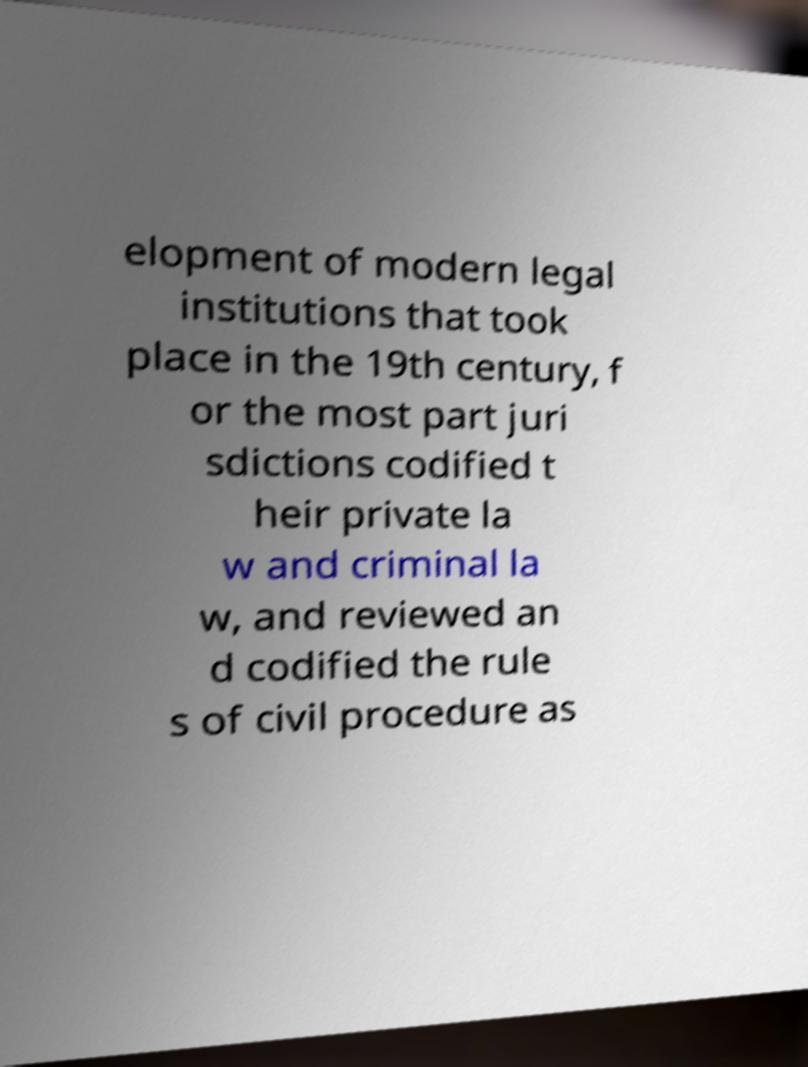There's text embedded in this image that I need extracted. Can you transcribe it verbatim? elopment of modern legal institutions that took place in the 19th century, f or the most part juri sdictions codified t heir private la w and criminal la w, and reviewed an d codified the rule s of civil procedure as 